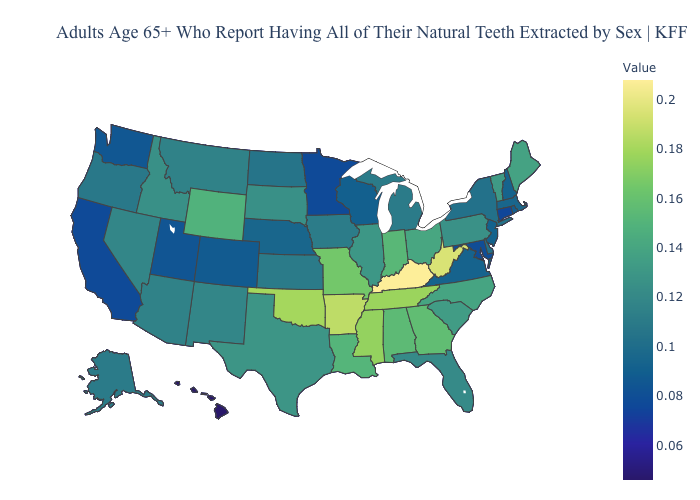Which states have the lowest value in the USA?
Quick response, please. Hawaii. Does Maryland have the highest value in the USA?
Give a very brief answer. No. Which states have the lowest value in the USA?
Quick response, please. Hawaii. Which states hav the highest value in the South?
Quick response, please. Kentucky. Which states hav the highest value in the South?
Short answer required. Kentucky. Which states have the highest value in the USA?
Be succinct. Kentucky. Among the states that border New York , which have the highest value?
Be succinct. Vermont. 